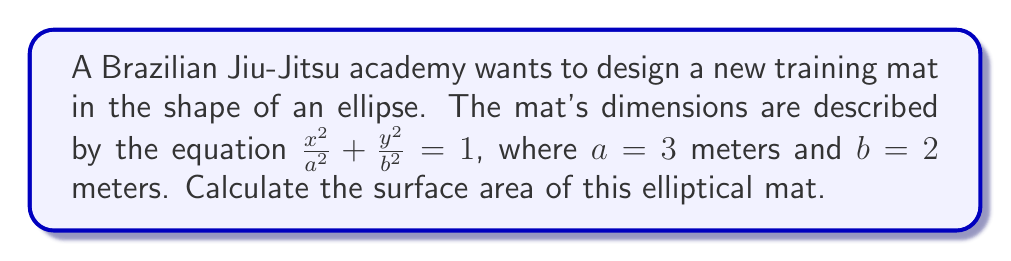Help me with this question. To calculate the surface area of the elliptical mat, we'll use the following steps:

1. The formula for the surface area of an ellipse is:
   $$ A = \pi ab $$
   where $a$ and $b$ are the semi-major and semi-minor axes, respectively.

2. We are given that $a = 3$ meters and $b = 2$ meters.

3. Substituting these values into the formula:
   $$ A = \pi \cdot 3 \cdot 2 $$

4. Simplify:
   $$ A = 6\pi $$

5. To get a decimal approximation:
   $$ A \approx 6 \cdot 3.14159 \approx 18.85 $$

Therefore, the surface area of the elliptical training mat is $6\pi$ square meters, or approximately 18.85 square meters.

[asy]
import geometry;

size(200);
ellipse e = ellipse((0,0), 3, 2);
draw(e);
label("3m", (3,0), E);
label("2m", (0,2), N);
draw((0,0)--(3,0), arrow=Arrow(TeXHead));
draw((0,0)--(0,2), arrow=Arrow(TeXHead));
[/asy]
Answer: $6\pi$ square meters 